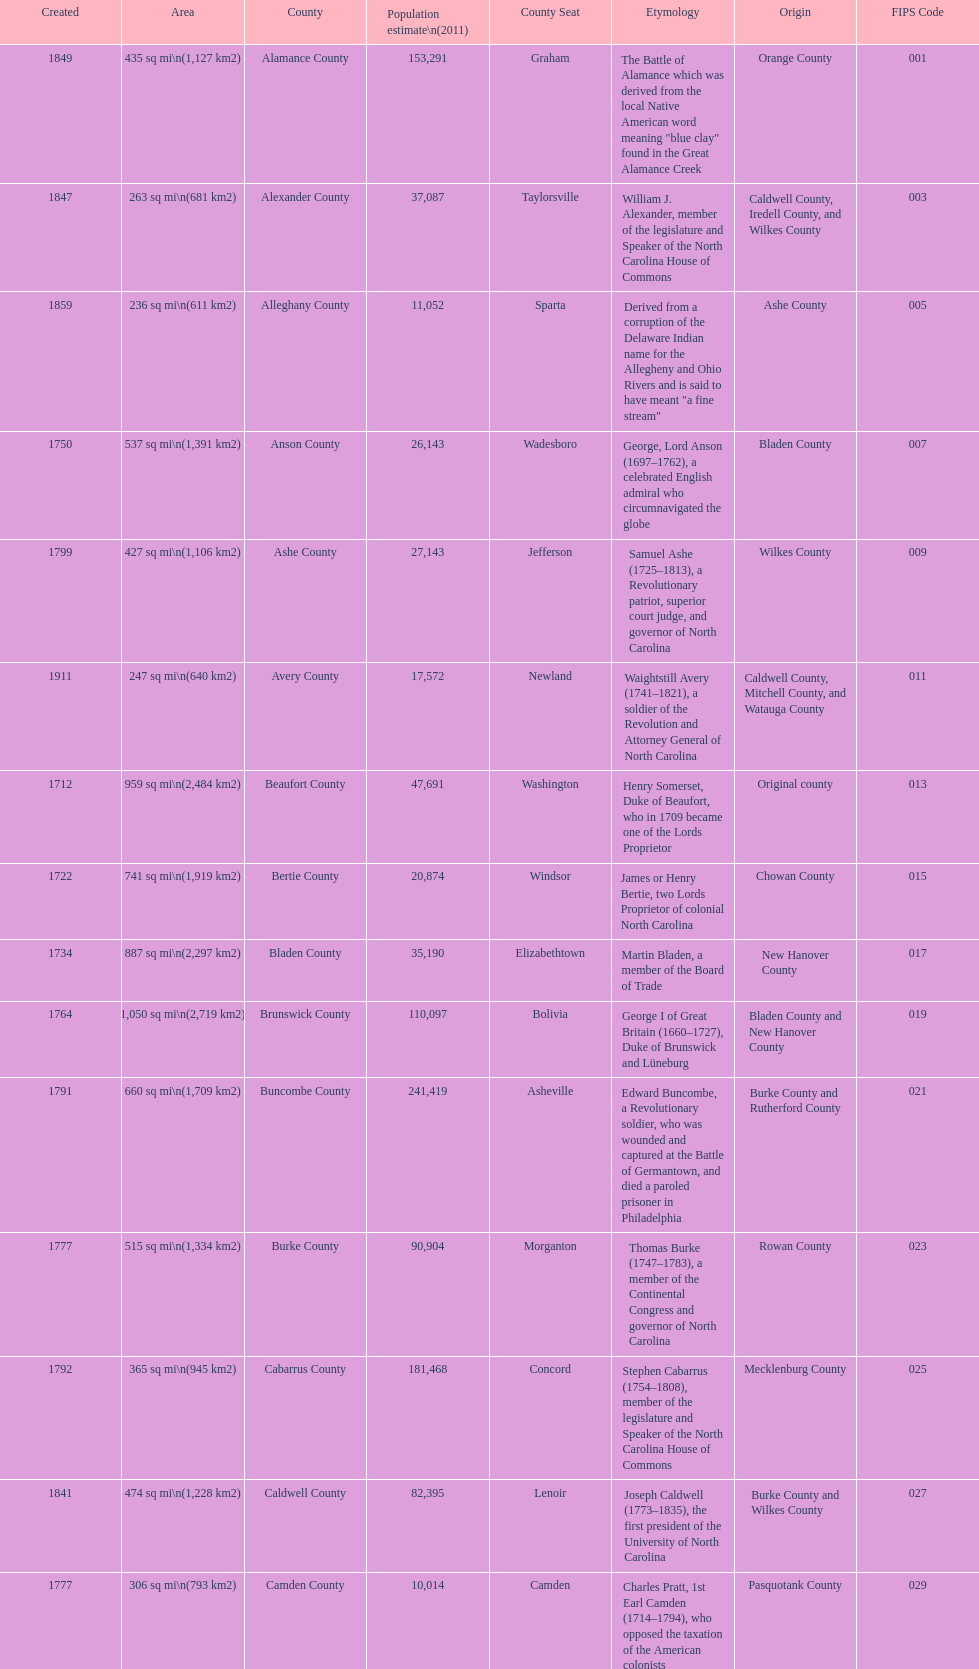What number of counties are named for us presidents? 3. 